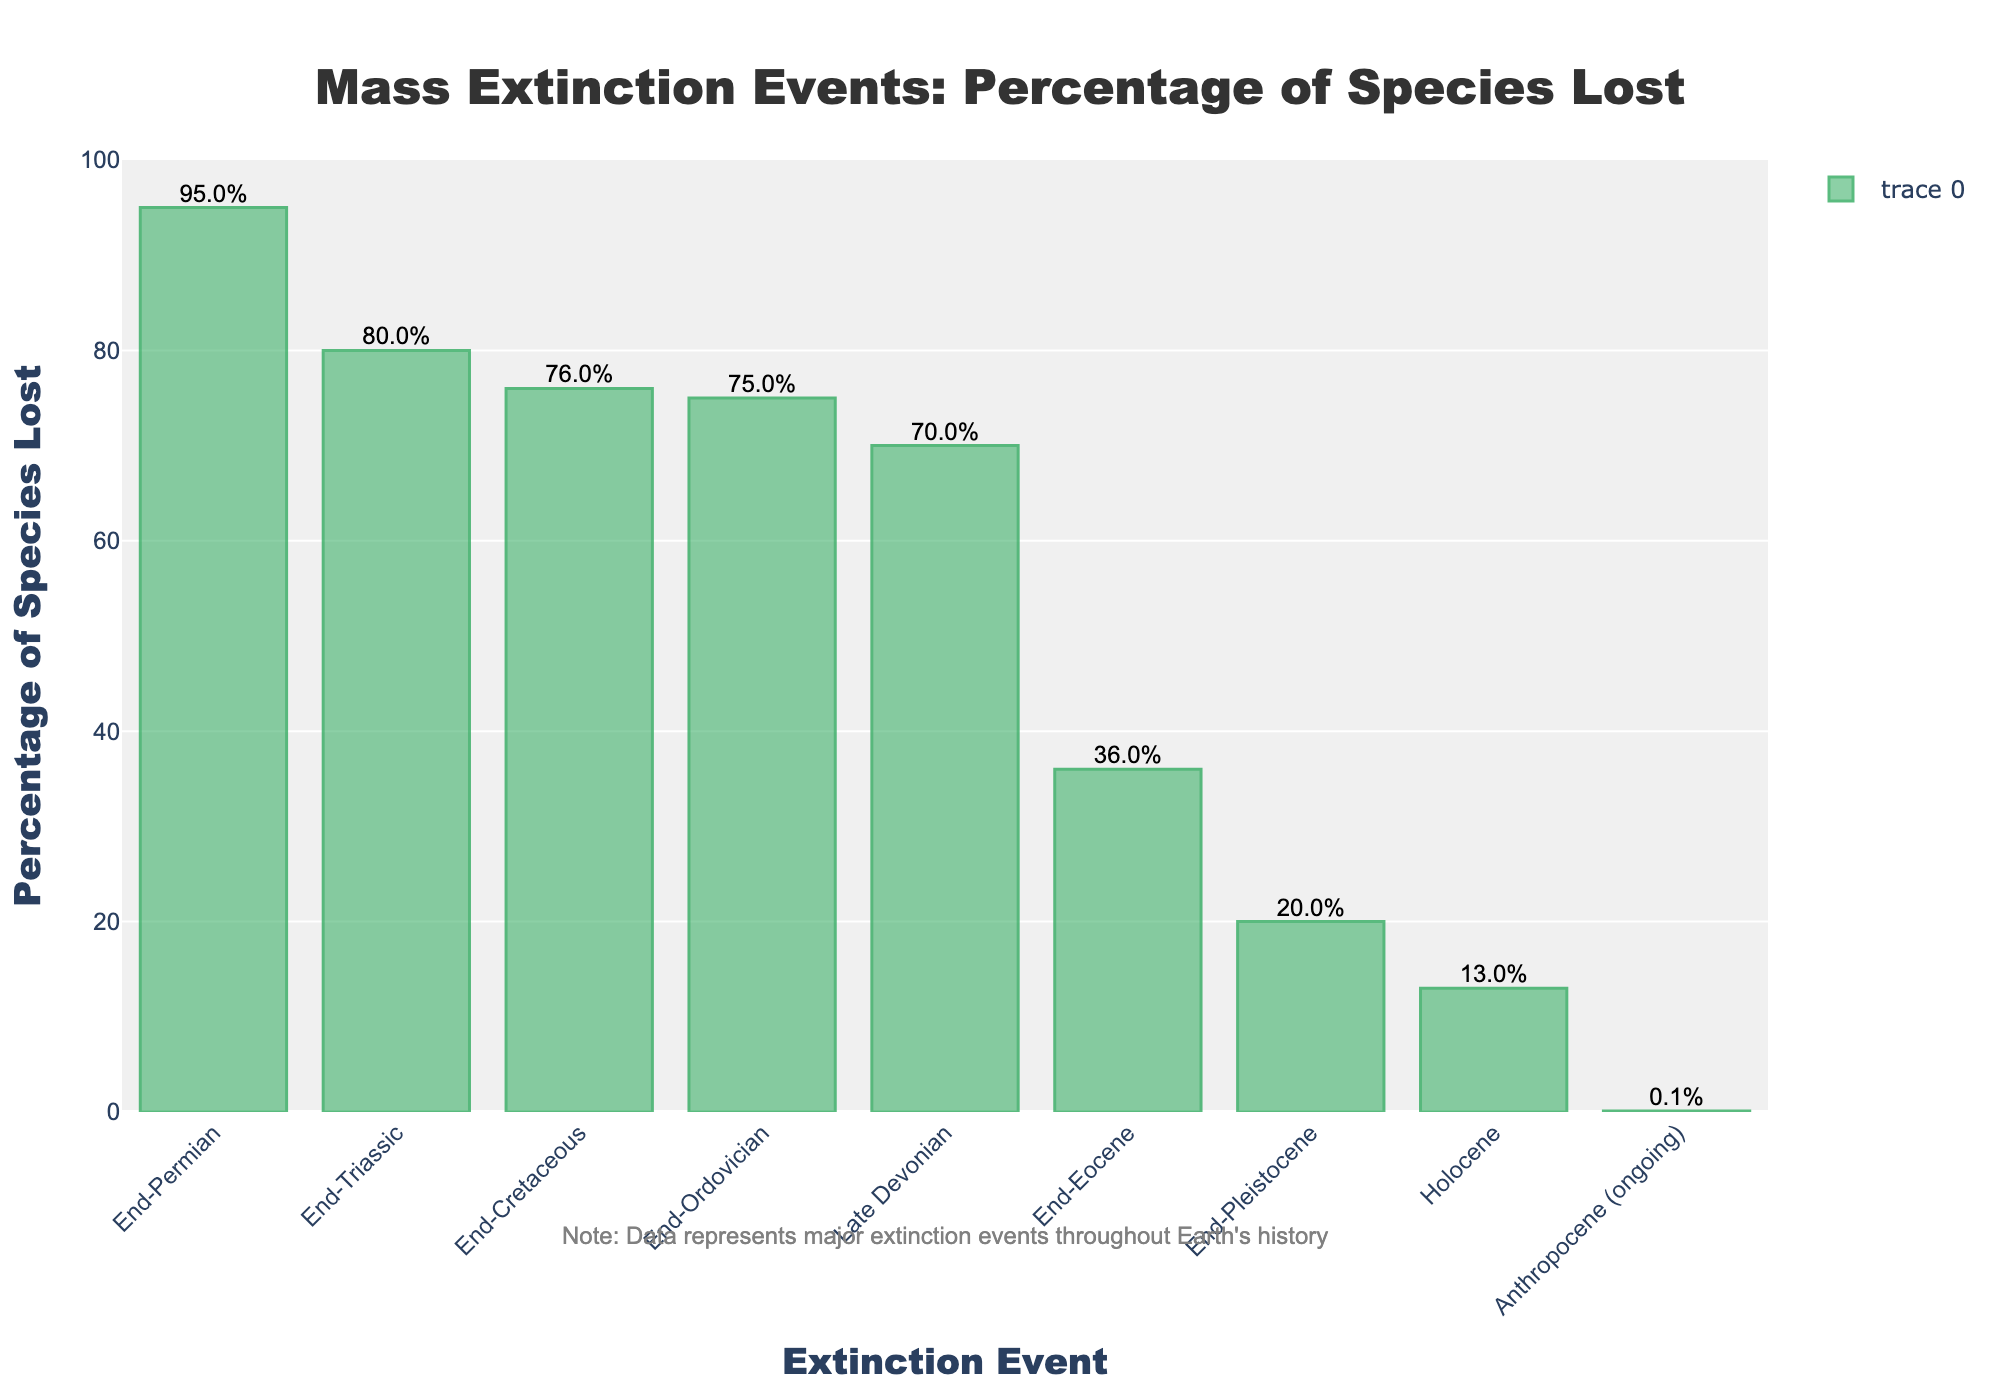Which extinction event had the highest percentage of species lost? To identify this, look at the bar with the highest length. The 'End-Permian' event has the tallest bar, indicating the highest percentage.
Answer: End-Permian Which extinction event had the lowest percentage of species lost? To find this, observe the bar with the shortest length. The 'Anthropocene (ongoing)' event has the shortest bar, indicating the lowest percentage of species loss.
Answer: Anthropocene (ongoing) What is the difference in percentage of species lost between the End-Permian and the End-Cretaceous events? Subtract the percentage of species lost in the End-Cretaceous (76%) from the End-Permian (95%). 95% - 76% = 19%.
Answer: 19% How many extinction events had a percentage of species lost greater than or equal to 75%? Look at the bars with heights equal to or greater than 75%. There are four bars: End-Ordovician (75%), Late Devonian (70%), End-Permian (95%), and End-Triassic (80%).
Answer: 4 Which event had a percentage of species lost that is closest to 80%? Compare the values to 80% and find the nearest one. 'End-Triassic' has a percentage of 80%, which is closest.
Answer: End-Triassic What is the average percentage of species lost in the End-Permian, End-Ordovician, and End-Cretaceous events? Add the percentages of the three events: 95% (End-Permian) + 75% (End-Ordovician) + 76% (End-Cretaceous). Then, divide by 3 to find the average. (95 + 75 + 76) / 3 = 82%.
Answer: 82% How much greater is the percentage of species lost in the End-Pleistocene event compared to the Holocene event? Subtract the percentage lost in Holocene (13%) from the percentage lost in End-Pleistocene (20%). 20% - 13% = 7%.
Answer: 7% What percentage of species were lost in the Late Devonian event according to the chart? Check the bar corresponding to 'Late Devonian' and note the percentage shown. The Late Devonian event shows 70% species lost.
Answer: 70% 